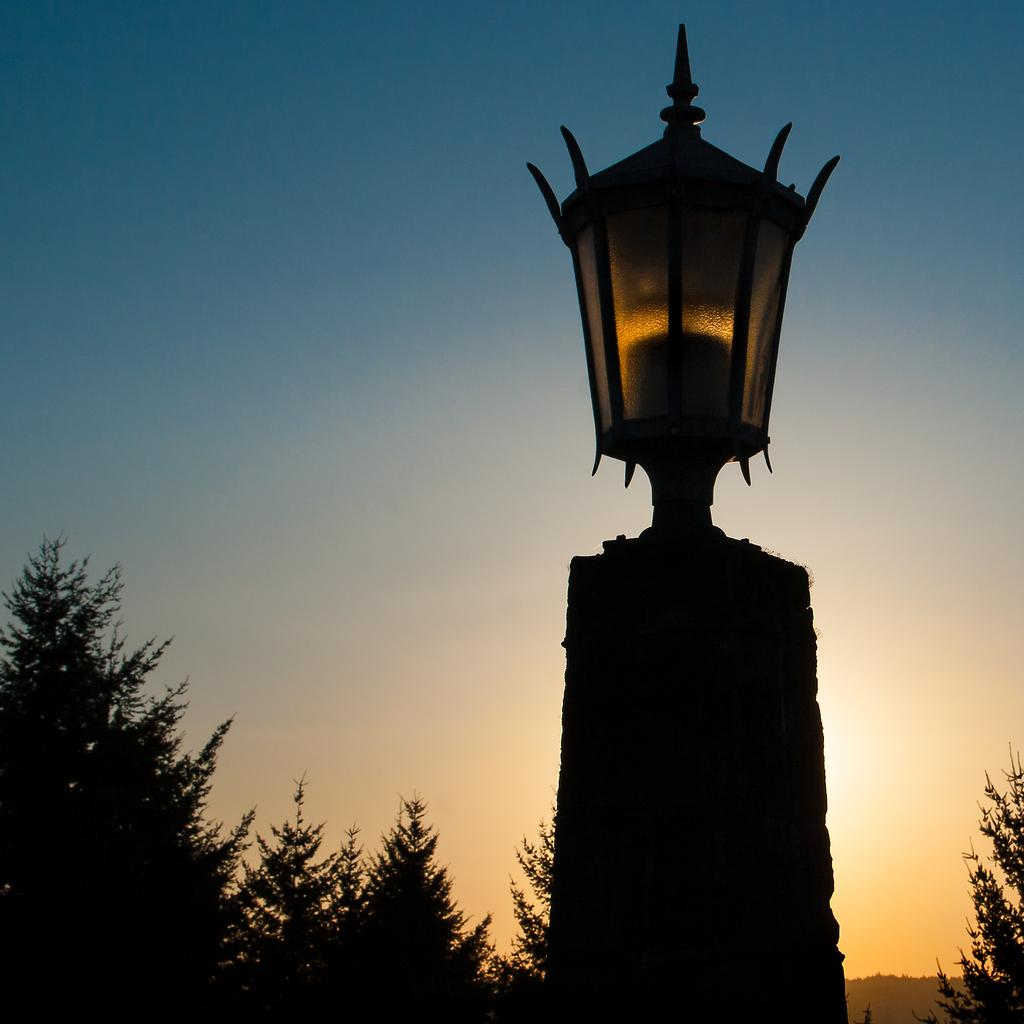What object is located in the foreground of the image? There is a lamp on a pole in the foreground of the image. What type of vegetation can be seen in the background of the image? There are trees in the background of the image. What is visible in the sky in the background of the image? The sky is visible in the background of the image. Can you tell me how many cows are grazing in the image? There are no cows present in the image; it features a lamp on a pole and trees in the background. What direction does the mother turn in the image? There is no mother present in the image, so it is not possible to determine the direction she turns. 